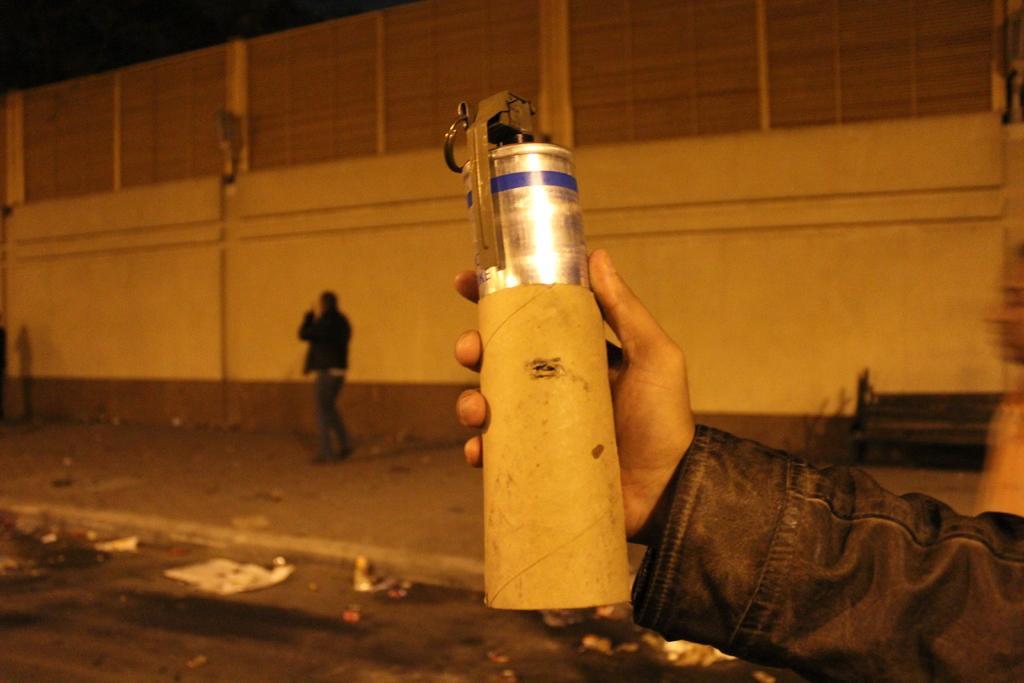Describe this image in one or two sentences. At the right bottom of the image there is a person hand with a black jacket is holding the steel bottle in the hand. Behind the hand there is a person standing on the footpath. In the background there is a wall. 